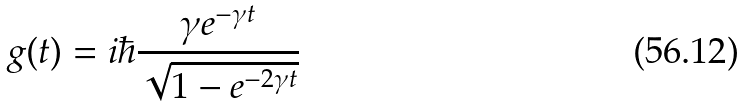Convert formula to latex. <formula><loc_0><loc_0><loc_500><loc_500>g ( t ) = i \hbar { \frac { \gamma e ^ { - \gamma t } } { \sqrt { 1 - e ^ { - 2 \gamma t } } } }</formula> 